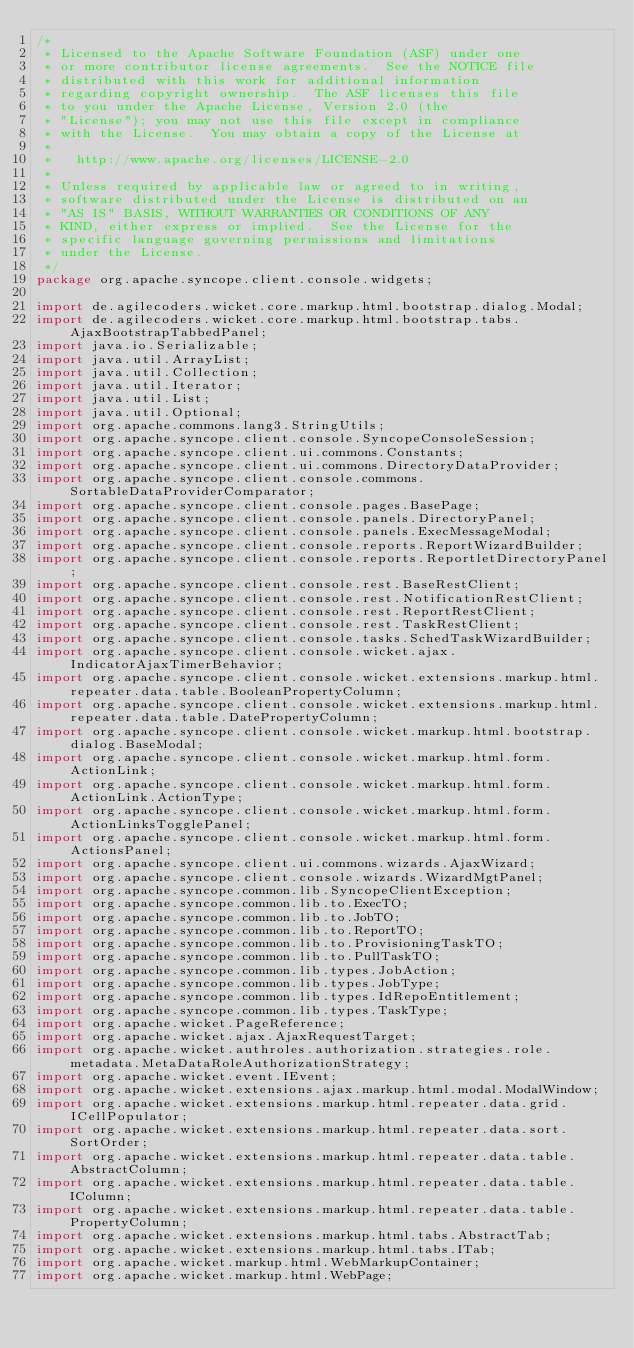Convert code to text. <code><loc_0><loc_0><loc_500><loc_500><_Java_>/*
 * Licensed to the Apache Software Foundation (ASF) under one
 * or more contributor license agreements.  See the NOTICE file
 * distributed with this work for additional information
 * regarding copyright ownership.  The ASF licenses this file
 * to you under the Apache License, Version 2.0 (the
 * "License"); you may not use this file except in compliance
 * with the License.  You may obtain a copy of the License at
 *
 *   http://www.apache.org/licenses/LICENSE-2.0
 *
 * Unless required by applicable law or agreed to in writing,
 * software distributed under the License is distributed on an
 * "AS IS" BASIS, WITHOUT WARRANTIES OR CONDITIONS OF ANY
 * KIND, either express or implied.  See the License for the
 * specific language governing permissions and limitations
 * under the License.
 */
package org.apache.syncope.client.console.widgets;

import de.agilecoders.wicket.core.markup.html.bootstrap.dialog.Modal;
import de.agilecoders.wicket.core.markup.html.bootstrap.tabs.AjaxBootstrapTabbedPanel;
import java.io.Serializable;
import java.util.ArrayList;
import java.util.Collection;
import java.util.Iterator;
import java.util.List;
import java.util.Optional;
import org.apache.commons.lang3.StringUtils;
import org.apache.syncope.client.console.SyncopeConsoleSession;
import org.apache.syncope.client.ui.commons.Constants;
import org.apache.syncope.client.ui.commons.DirectoryDataProvider;
import org.apache.syncope.client.console.commons.SortableDataProviderComparator;
import org.apache.syncope.client.console.pages.BasePage;
import org.apache.syncope.client.console.panels.DirectoryPanel;
import org.apache.syncope.client.console.panels.ExecMessageModal;
import org.apache.syncope.client.console.reports.ReportWizardBuilder;
import org.apache.syncope.client.console.reports.ReportletDirectoryPanel;
import org.apache.syncope.client.console.rest.BaseRestClient;
import org.apache.syncope.client.console.rest.NotificationRestClient;
import org.apache.syncope.client.console.rest.ReportRestClient;
import org.apache.syncope.client.console.rest.TaskRestClient;
import org.apache.syncope.client.console.tasks.SchedTaskWizardBuilder;
import org.apache.syncope.client.console.wicket.ajax.IndicatorAjaxTimerBehavior;
import org.apache.syncope.client.console.wicket.extensions.markup.html.repeater.data.table.BooleanPropertyColumn;
import org.apache.syncope.client.console.wicket.extensions.markup.html.repeater.data.table.DatePropertyColumn;
import org.apache.syncope.client.console.wicket.markup.html.bootstrap.dialog.BaseModal;
import org.apache.syncope.client.console.wicket.markup.html.form.ActionLink;
import org.apache.syncope.client.console.wicket.markup.html.form.ActionLink.ActionType;
import org.apache.syncope.client.console.wicket.markup.html.form.ActionLinksTogglePanel;
import org.apache.syncope.client.console.wicket.markup.html.form.ActionsPanel;
import org.apache.syncope.client.ui.commons.wizards.AjaxWizard;
import org.apache.syncope.client.console.wizards.WizardMgtPanel;
import org.apache.syncope.common.lib.SyncopeClientException;
import org.apache.syncope.common.lib.to.ExecTO;
import org.apache.syncope.common.lib.to.JobTO;
import org.apache.syncope.common.lib.to.ReportTO;
import org.apache.syncope.common.lib.to.ProvisioningTaskTO;
import org.apache.syncope.common.lib.to.PullTaskTO;
import org.apache.syncope.common.lib.types.JobAction;
import org.apache.syncope.common.lib.types.JobType;
import org.apache.syncope.common.lib.types.IdRepoEntitlement;
import org.apache.syncope.common.lib.types.TaskType;
import org.apache.wicket.PageReference;
import org.apache.wicket.ajax.AjaxRequestTarget;
import org.apache.wicket.authroles.authorization.strategies.role.metadata.MetaDataRoleAuthorizationStrategy;
import org.apache.wicket.event.IEvent;
import org.apache.wicket.extensions.ajax.markup.html.modal.ModalWindow;
import org.apache.wicket.extensions.markup.html.repeater.data.grid.ICellPopulator;
import org.apache.wicket.extensions.markup.html.repeater.data.sort.SortOrder;
import org.apache.wicket.extensions.markup.html.repeater.data.table.AbstractColumn;
import org.apache.wicket.extensions.markup.html.repeater.data.table.IColumn;
import org.apache.wicket.extensions.markup.html.repeater.data.table.PropertyColumn;
import org.apache.wicket.extensions.markup.html.tabs.AbstractTab;
import org.apache.wicket.extensions.markup.html.tabs.ITab;
import org.apache.wicket.markup.html.WebMarkupContainer;
import org.apache.wicket.markup.html.WebPage;</code> 